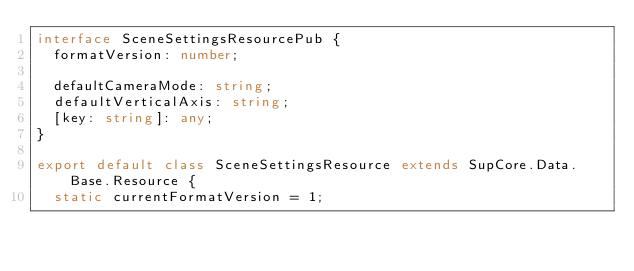Convert code to text. <code><loc_0><loc_0><loc_500><loc_500><_TypeScript_>interface SceneSettingsResourcePub {
  formatVersion: number;

  defaultCameraMode: string;
  defaultVerticalAxis: string;
  [key: string]: any;
}

export default class SceneSettingsResource extends SupCore.Data.Base.Resource {
  static currentFormatVersion = 1;
</code> 